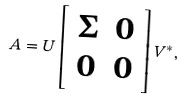<formula> <loc_0><loc_0><loc_500><loc_500>A = U \left [ \begin{array} { c c } \Sigma & 0 \\ 0 & 0 \end{array} \right ] V ^ { * } ,</formula> 